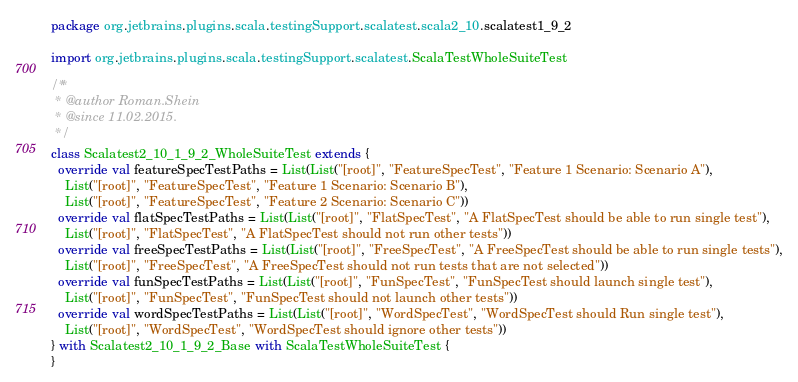Convert code to text. <code><loc_0><loc_0><loc_500><loc_500><_Scala_>package org.jetbrains.plugins.scala.testingSupport.scalatest.scala2_10.scalatest1_9_2

import org.jetbrains.plugins.scala.testingSupport.scalatest.ScalaTestWholeSuiteTest

/**
 * @author Roman.Shein
 * @since 11.02.2015.
 */
class Scalatest2_10_1_9_2_WholeSuiteTest extends {
  override val featureSpecTestPaths = List(List("[root]", "FeatureSpecTest", "Feature 1 Scenario: Scenario A"),
    List("[root]", "FeatureSpecTest", "Feature 1 Scenario: Scenario B"),
    List("[root]", "FeatureSpecTest", "Feature 2 Scenario: Scenario C"))
  override val flatSpecTestPaths = List(List("[root]", "FlatSpecTest", "A FlatSpecTest should be able to run single test"),
    List("[root]", "FlatSpecTest", "A FlatSpecTest should not run other tests"))
  override val freeSpecTestPaths = List(List("[root]", "FreeSpecTest", "A FreeSpecTest should be able to run single tests"),
    List("[root]", "FreeSpecTest", "A FreeSpecTest should not run tests that are not selected"))
  override val funSpecTestPaths = List(List("[root]", "FunSpecTest", "FunSpecTest should launch single test"),
    List("[root]", "FunSpecTest", "FunSpecTest should not launch other tests"))
  override val wordSpecTestPaths = List(List("[root]", "WordSpecTest", "WordSpecTest should Run single test"),
    List("[root]", "WordSpecTest", "WordSpecTest should ignore other tests"))
} with Scalatest2_10_1_9_2_Base with ScalaTestWholeSuiteTest {
}
</code> 